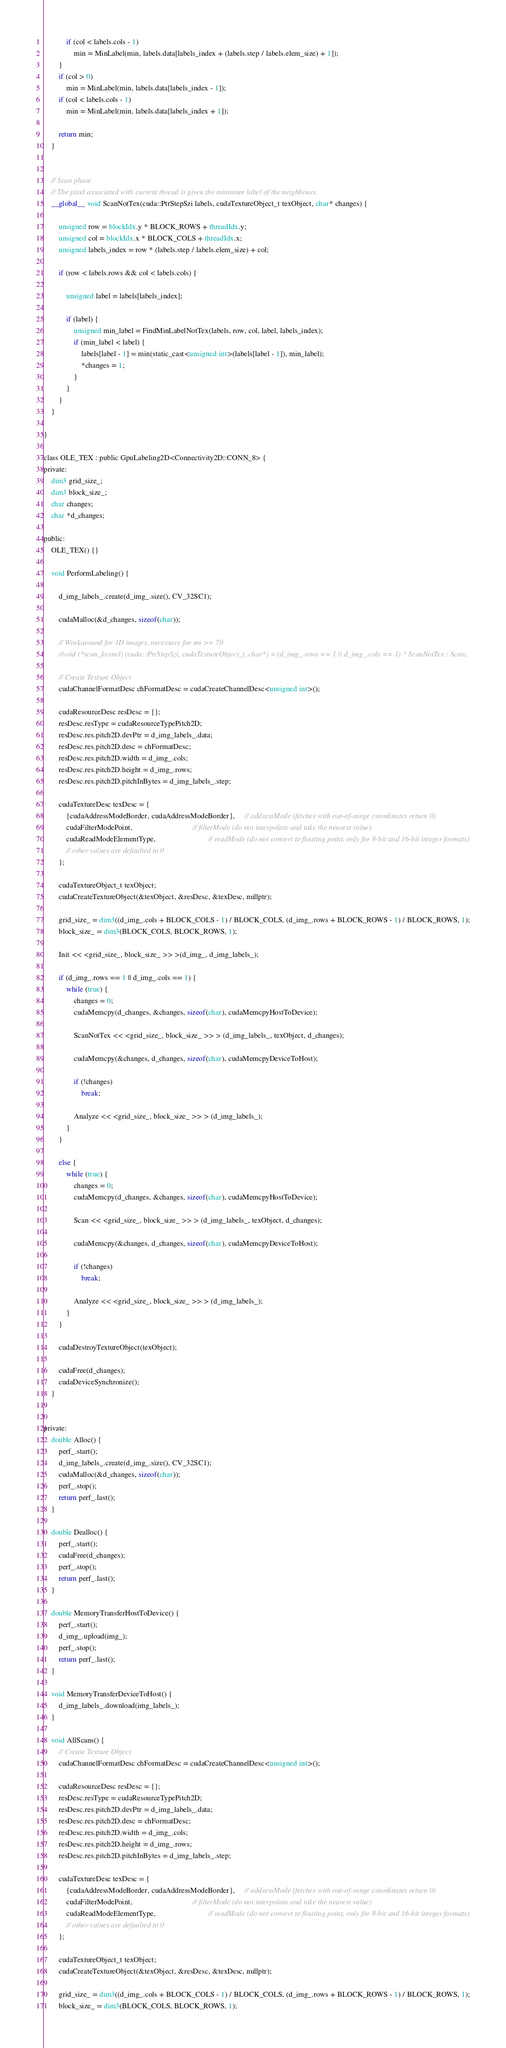<code> <loc_0><loc_0><loc_500><loc_500><_Cuda_>			if (col < labels.cols - 1)
				min = MinLabel(min, labels.data[labels_index + (labels.step / labels.elem_size) + 1]);
		}
		if (col > 0)
			min = MinLabel(min, labels.data[labels_index - 1]);
		if (col < labels.cols - 1)
			min = MinLabel(min, labels.data[labels_index + 1]);

		return min;
	}


	// Scan phase.
	// The pixel associated with current thread is given the minimum label of the neighbours.
	__global__ void ScanNotTex(cuda::PtrStepSzi labels, cudaTextureObject_t texObject, char* changes) {

		unsigned row = blockIdx.y * BLOCK_ROWS + threadIdx.y;
		unsigned col = blockIdx.x * BLOCK_COLS + threadIdx.x;
		unsigned labels_index = row * (labels.step / labels.elem_size) + col;

		if (row < labels.rows && col < labels.cols) {

			unsigned label = labels[labels_index];

			if (label) {
				unsigned min_label = FindMinLabelNotTex(labels, row, col, label, labels_index);
				if (min_label < label) {
					labels[label - 1] = min(static_cast<unsigned int>(labels[label - 1]), min_label);
					*changes = 1;
				}
			}
		}
	}

}

class OLE_TEX : public GpuLabeling2D<Connectivity2D::CONN_8> {
private:
	dim3 grid_size_;
	dim3 block_size_;
	char changes;
	char *d_changes;

public:
	OLE_TEX() {}

	void PerformLabeling() {

		d_img_labels_.create(d_img_.size(), CV_32SC1);

		cudaMalloc(&d_changes, sizeof(char));

		// Workaround for 1D images, necessary for sm >= 70
		//void (*scan_kernel) (cuda::PtrStepSzi, cudaTextureObject_t, char*) = (d_img_.rows == 1 || d_img_.cols == 1) ? ScanNotTex : Scan;

		// Create Texture Object
		cudaChannelFormatDesc chFormatDesc = cudaCreateChannelDesc<unsigned int>();

		cudaResourceDesc resDesc = {};
		resDesc.resType = cudaResourceTypePitch2D;
		resDesc.res.pitch2D.devPtr = d_img_labels_.data;
		resDesc.res.pitch2D.desc = chFormatDesc;
		resDesc.res.pitch2D.width = d_img_.cols;
		resDesc.res.pitch2D.height = d_img_.rows;
		resDesc.res.pitch2D.pitchInBytes = d_img_labels_.step;

		cudaTextureDesc texDesc = {
			{cudaAddressModeBorder, cudaAddressModeBorder},     // addressMode (fetches with out-of-range coordinates return 0)
			cudaFilterModePoint,                                // filterMode (do not interpolate and take the nearest value)
			cudaReadModeElementType,                            // readMode (do not convert to floating point, only for 8-bit and 16-bit integer formats)
			// other values are defaulted to 0
		};

		cudaTextureObject_t texObject;
		cudaCreateTextureObject(&texObject, &resDesc, &texDesc, nullptr);

		grid_size_ = dim3((d_img_.cols + BLOCK_COLS - 1) / BLOCK_COLS, (d_img_.rows + BLOCK_ROWS - 1) / BLOCK_ROWS, 1);
		block_size_ = dim3(BLOCK_COLS, BLOCK_ROWS, 1);

		Init << <grid_size_, block_size_ >> >(d_img_, d_img_labels_);

		if (d_img_.rows == 1 || d_img_.cols == 1) {
			while (true) {
				changes = 0;
				cudaMemcpy(d_changes, &changes, sizeof(char), cudaMemcpyHostToDevice);

				ScanNotTex << <grid_size_, block_size_ >> > (d_img_labels_, texObject, d_changes);

				cudaMemcpy(&changes, d_changes, sizeof(char), cudaMemcpyDeviceToHost);

				if (!changes)
					break;

				Analyze << <grid_size_, block_size_ >> > (d_img_labels_);
			}
		}

		else {
			while (true) {
				changes = 0;
				cudaMemcpy(d_changes, &changes, sizeof(char), cudaMemcpyHostToDevice);

				Scan << <grid_size_, block_size_ >> > (d_img_labels_, texObject, d_changes);

				cudaMemcpy(&changes, d_changes, sizeof(char), cudaMemcpyDeviceToHost);

				if (!changes)
					break;

				Analyze << <grid_size_, block_size_ >> > (d_img_labels_);
			}
		}

		cudaDestroyTextureObject(texObject);

		cudaFree(d_changes);
		cudaDeviceSynchronize();
	}


private:
	double Alloc() {
		perf_.start();
		d_img_labels_.create(d_img_.size(), CV_32SC1);
		cudaMalloc(&d_changes, sizeof(char));
		perf_.stop();
		return perf_.last();
	}

	double Dealloc() {
		perf_.start();
		cudaFree(d_changes);
		perf_.stop();
		return perf_.last();
	}

	double MemoryTransferHostToDevice() {
		perf_.start();
		d_img_.upload(img_);
		perf_.stop();
		return perf_.last();
	}

	void MemoryTransferDeviceToHost() {
		d_img_labels_.download(img_labels_);
	}

	void AllScans() {
		// Create Texture Object
		cudaChannelFormatDesc chFormatDesc = cudaCreateChannelDesc<unsigned int>();

		cudaResourceDesc resDesc = {};
		resDesc.resType = cudaResourceTypePitch2D;
		resDesc.res.pitch2D.devPtr = d_img_labels_.data;
		resDesc.res.pitch2D.desc = chFormatDesc;
		resDesc.res.pitch2D.width = d_img_.cols;
		resDesc.res.pitch2D.height = d_img_.rows;
		resDesc.res.pitch2D.pitchInBytes = d_img_labels_.step;

		cudaTextureDesc texDesc = {
			{cudaAddressModeBorder, cudaAddressModeBorder},     // addressMode (fetches with out-of-range coordinates return 0)
			cudaFilterModePoint,                                // filterMode (do not interpolate and take the nearest value)
			cudaReadModeElementType,                            // readMode (do not convert to floating point, only for 8-bit and 16-bit integer formats)
			// other values are defaulted to 0
		};

		cudaTextureObject_t texObject;
		cudaCreateTextureObject(&texObject, &resDesc, &texDesc, nullptr);

		grid_size_ = dim3((d_img_.cols + BLOCK_COLS - 1) / BLOCK_COLS, (d_img_.rows + BLOCK_ROWS - 1) / BLOCK_ROWS, 1);
		block_size_ = dim3(BLOCK_COLS, BLOCK_ROWS, 1);
</code> 